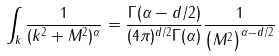<formula> <loc_0><loc_0><loc_500><loc_500>\int _ { k } \frac { 1 } { ( { k } ^ { 2 } + M ^ { 2 } ) ^ { \alpha } } = \frac { \Gamma ( \alpha - d / 2 ) } { ( 4 \pi ) ^ { d / 2 } \Gamma ( \alpha ) } \frac { 1 } { \left ( M ^ { 2 } \right ) ^ { \alpha - d / 2 } }</formula> 